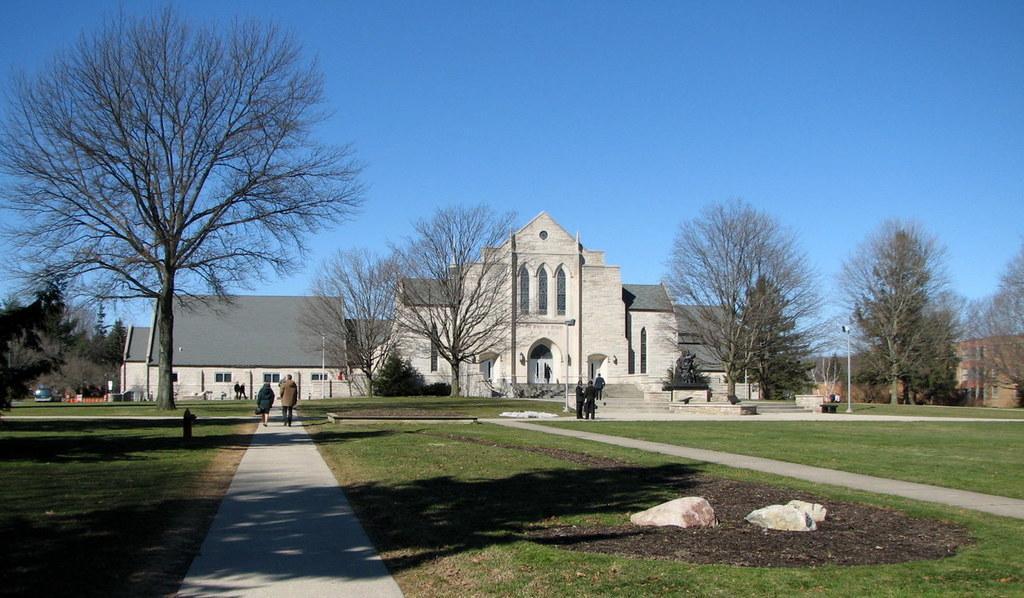Could you give a brief overview of what you see in this image? In this image there is a building in the middle. At the top there is the sky. In front of the building there is a garden. On the left side there is a path on which there are few people walking on it. There are trees on either side of the building. At the bottom there are stones. 